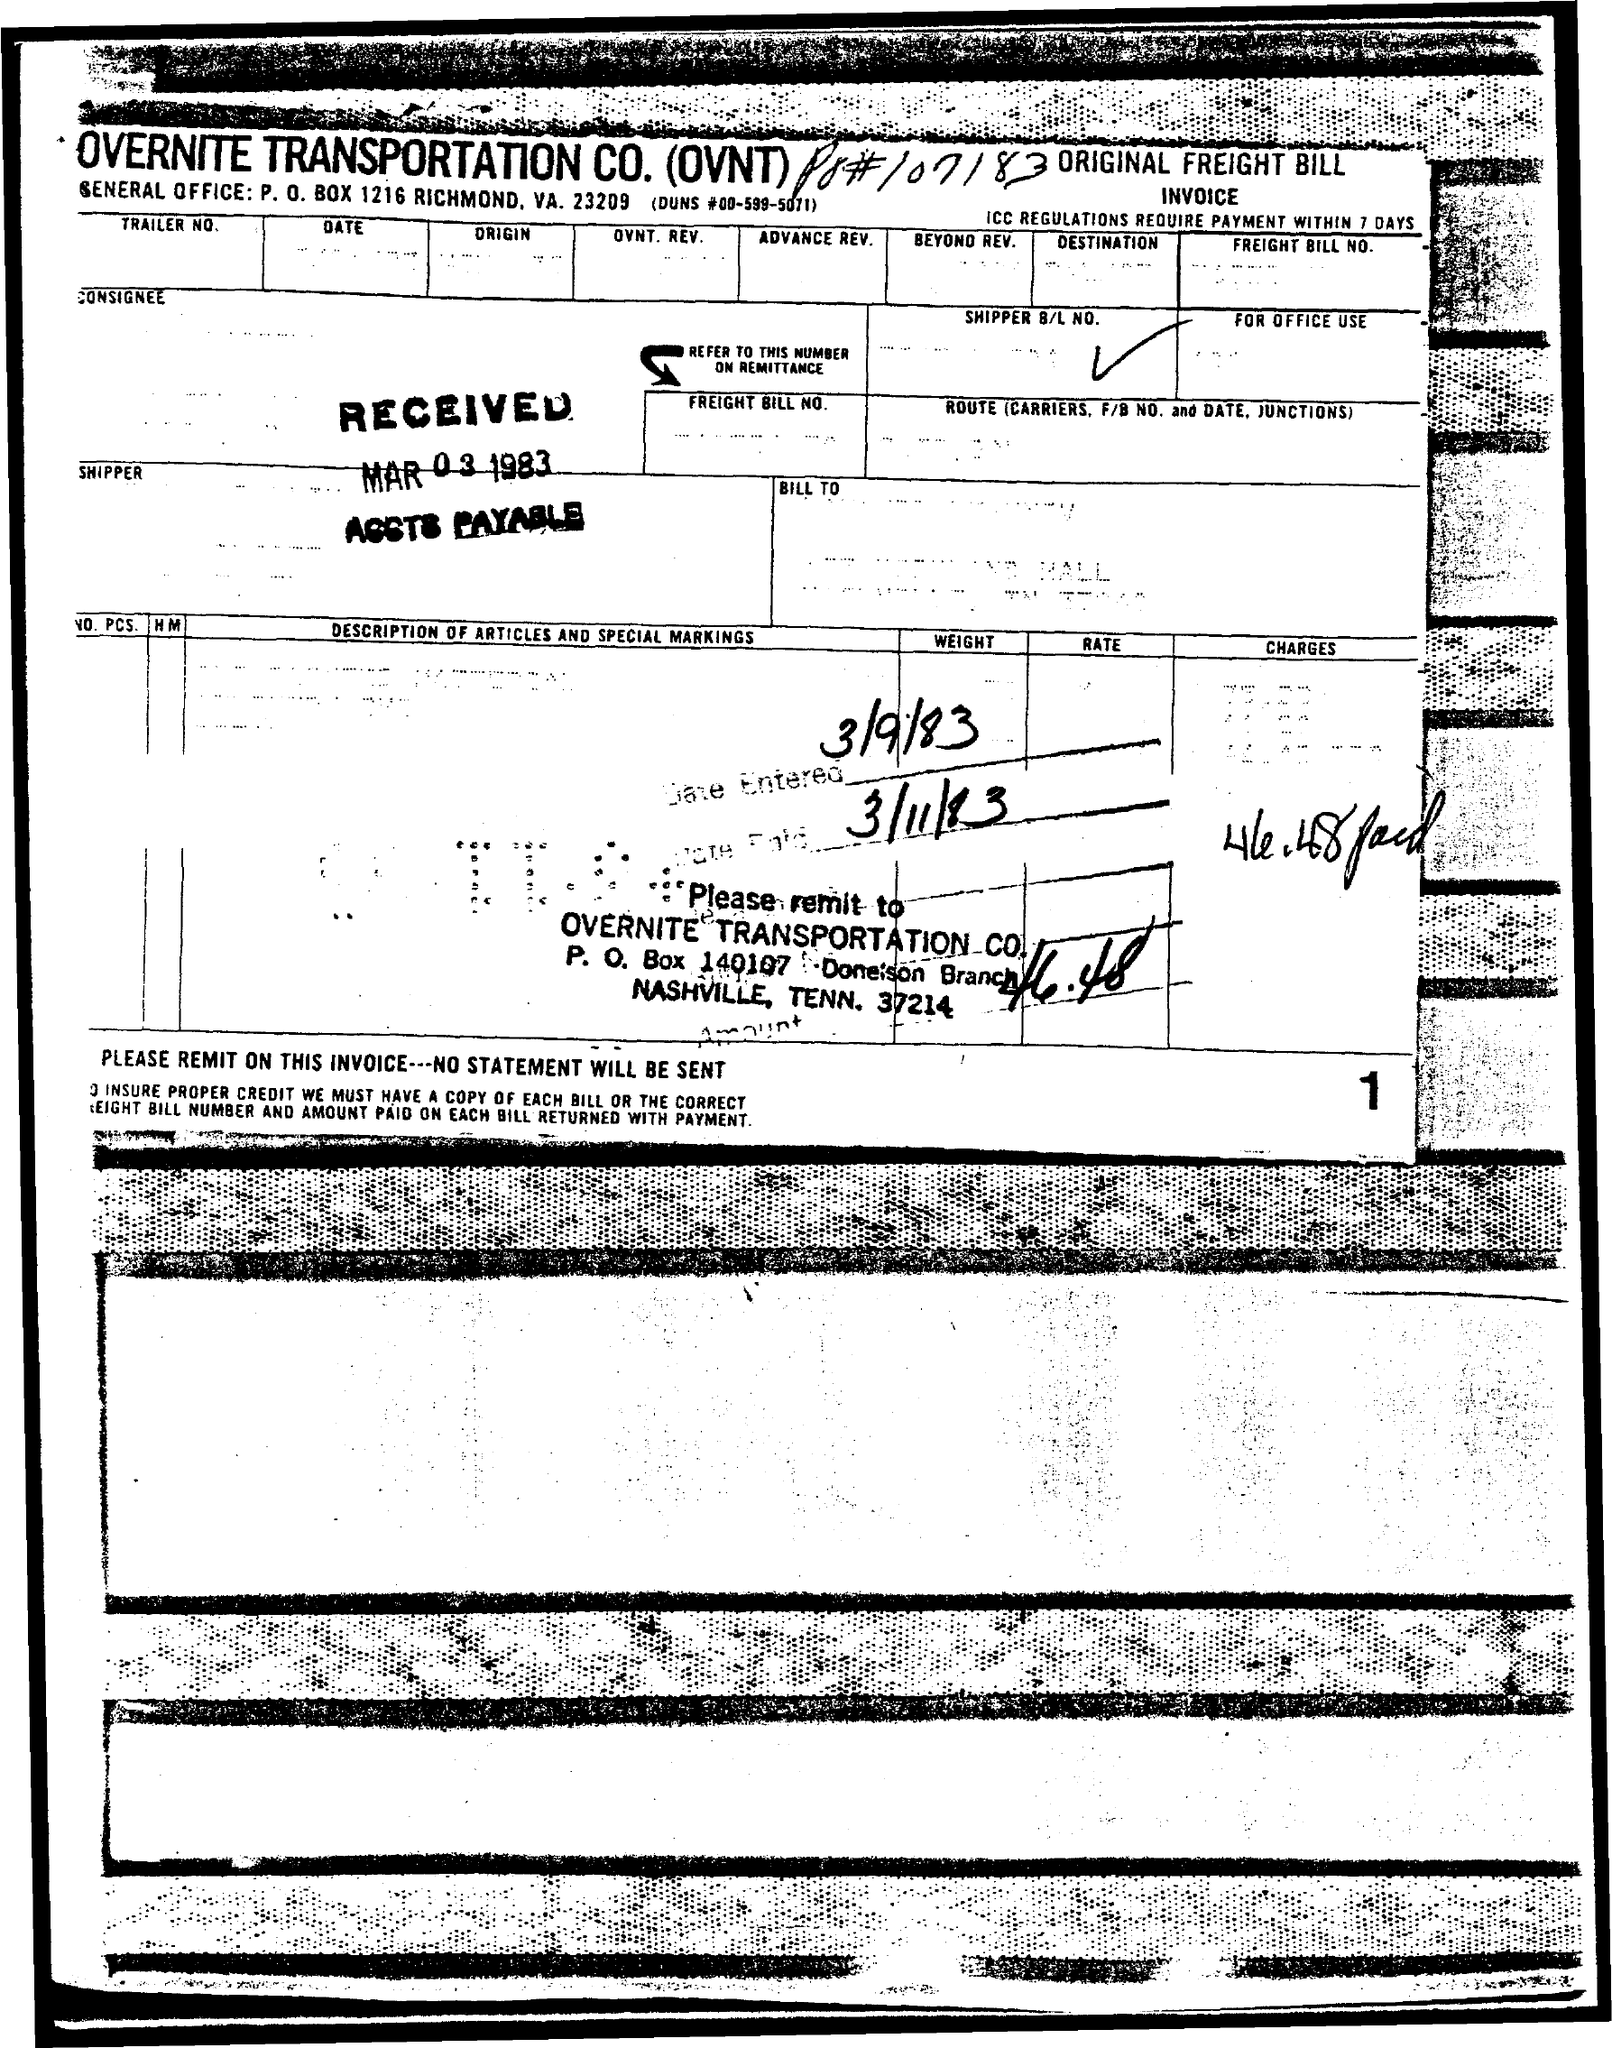List a handful of essential elements in this visual. What is the number at the bottom right of the document? The number is 1. The received date is March 3, 1983. 